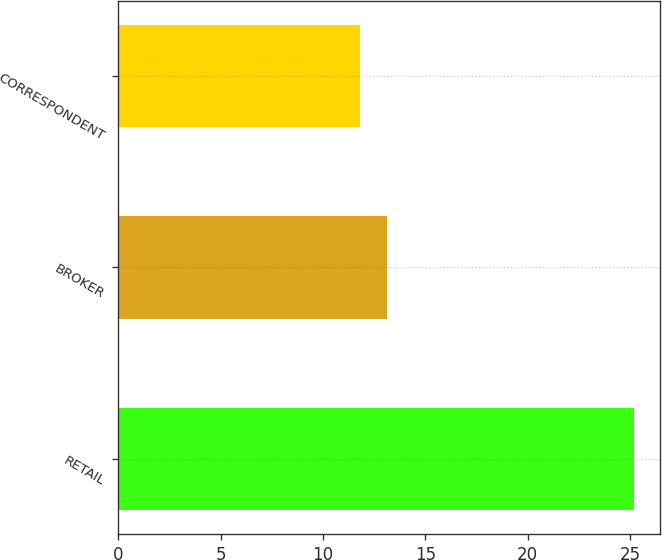Convert chart to OTSL. <chart><loc_0><loc_0><loc_500><loc_500><bar_chart><fcel>RETAIL<fcel>BROKER<fcel>CORRESPONDENT<nl><fcel>25.2<fcel>13.14<fcel>11.8<nl></chart> 